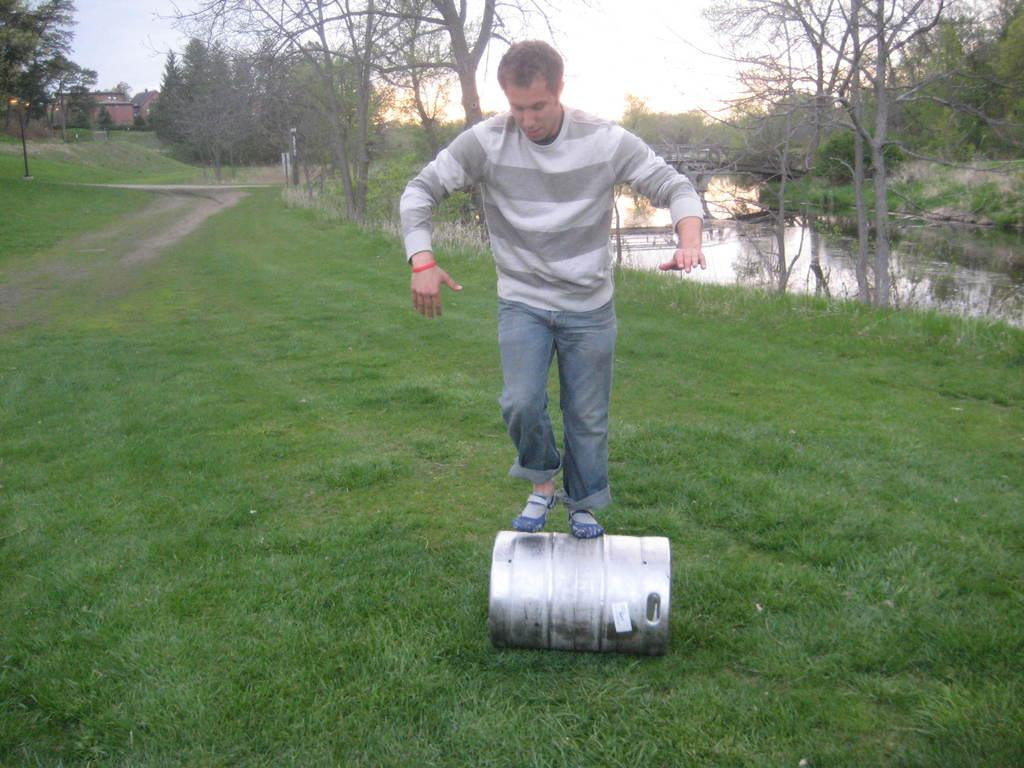What is the man doing in the image? The man is standing on a metal roller in the image. Where is the metal roller located? The metal roller is on land in the image. What can be seen on the right side of the image? There appears to be a pond on the right side of the image. What type of vegetation is present near the pond? Trees are present on either side of the pond in the image. What is visible above the pond and trees? The sky is visible above the pond and trees in the image. Reasoning: Let'ing: Let's think step by step in order to produce the conversation. We start by identifying the main subject in the image, which is the man standing on the metal roller. Then, we expand the conversation to include the location of the roller, the presence of the pond and trees, and the visibility of the sky. Each question is designed to elicit a specific detail about the image that is known from the provided facts. Absurd Question/Answer: What type of toys can be seen scattered around the tramp in the image? There is no tramp present in the image, and therefore no toys can be seen scattered around it. 